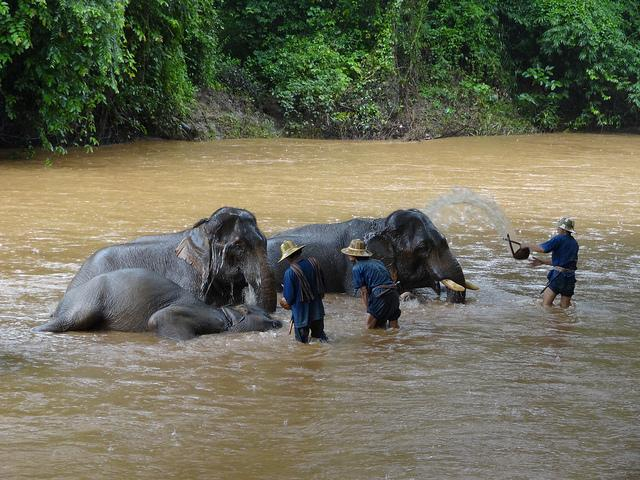Why is the water brown? dirt 